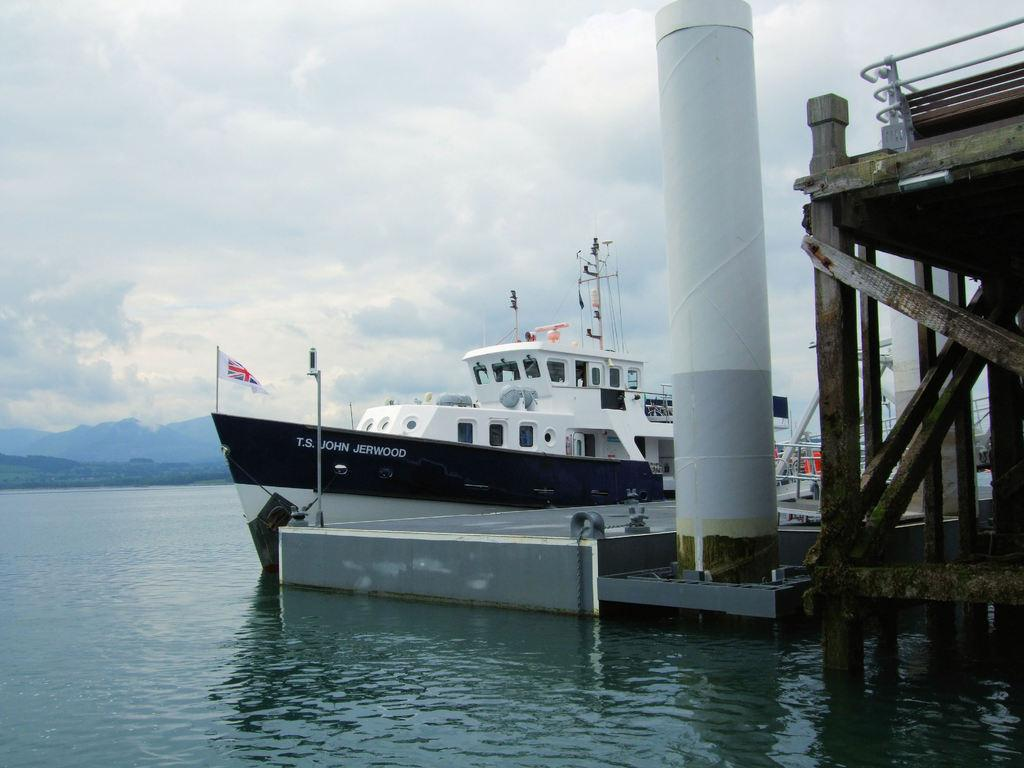<image>
Give a short and clear explanation of the subsequent image. A ferry boat named T.S. John Jerwood sits at the port in calm river waters 